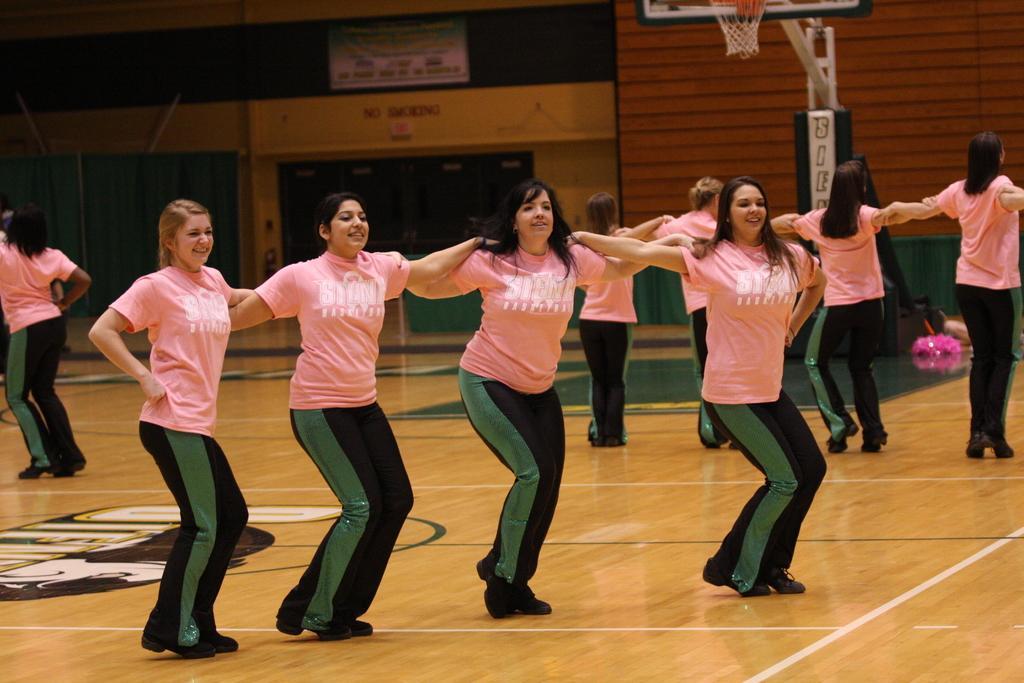Can you describe this image briefly? In this picture I can see a group of women are standing together. These women are wearing pink color t-shirts, pants and shoes. In the background I can see a board and basket. 